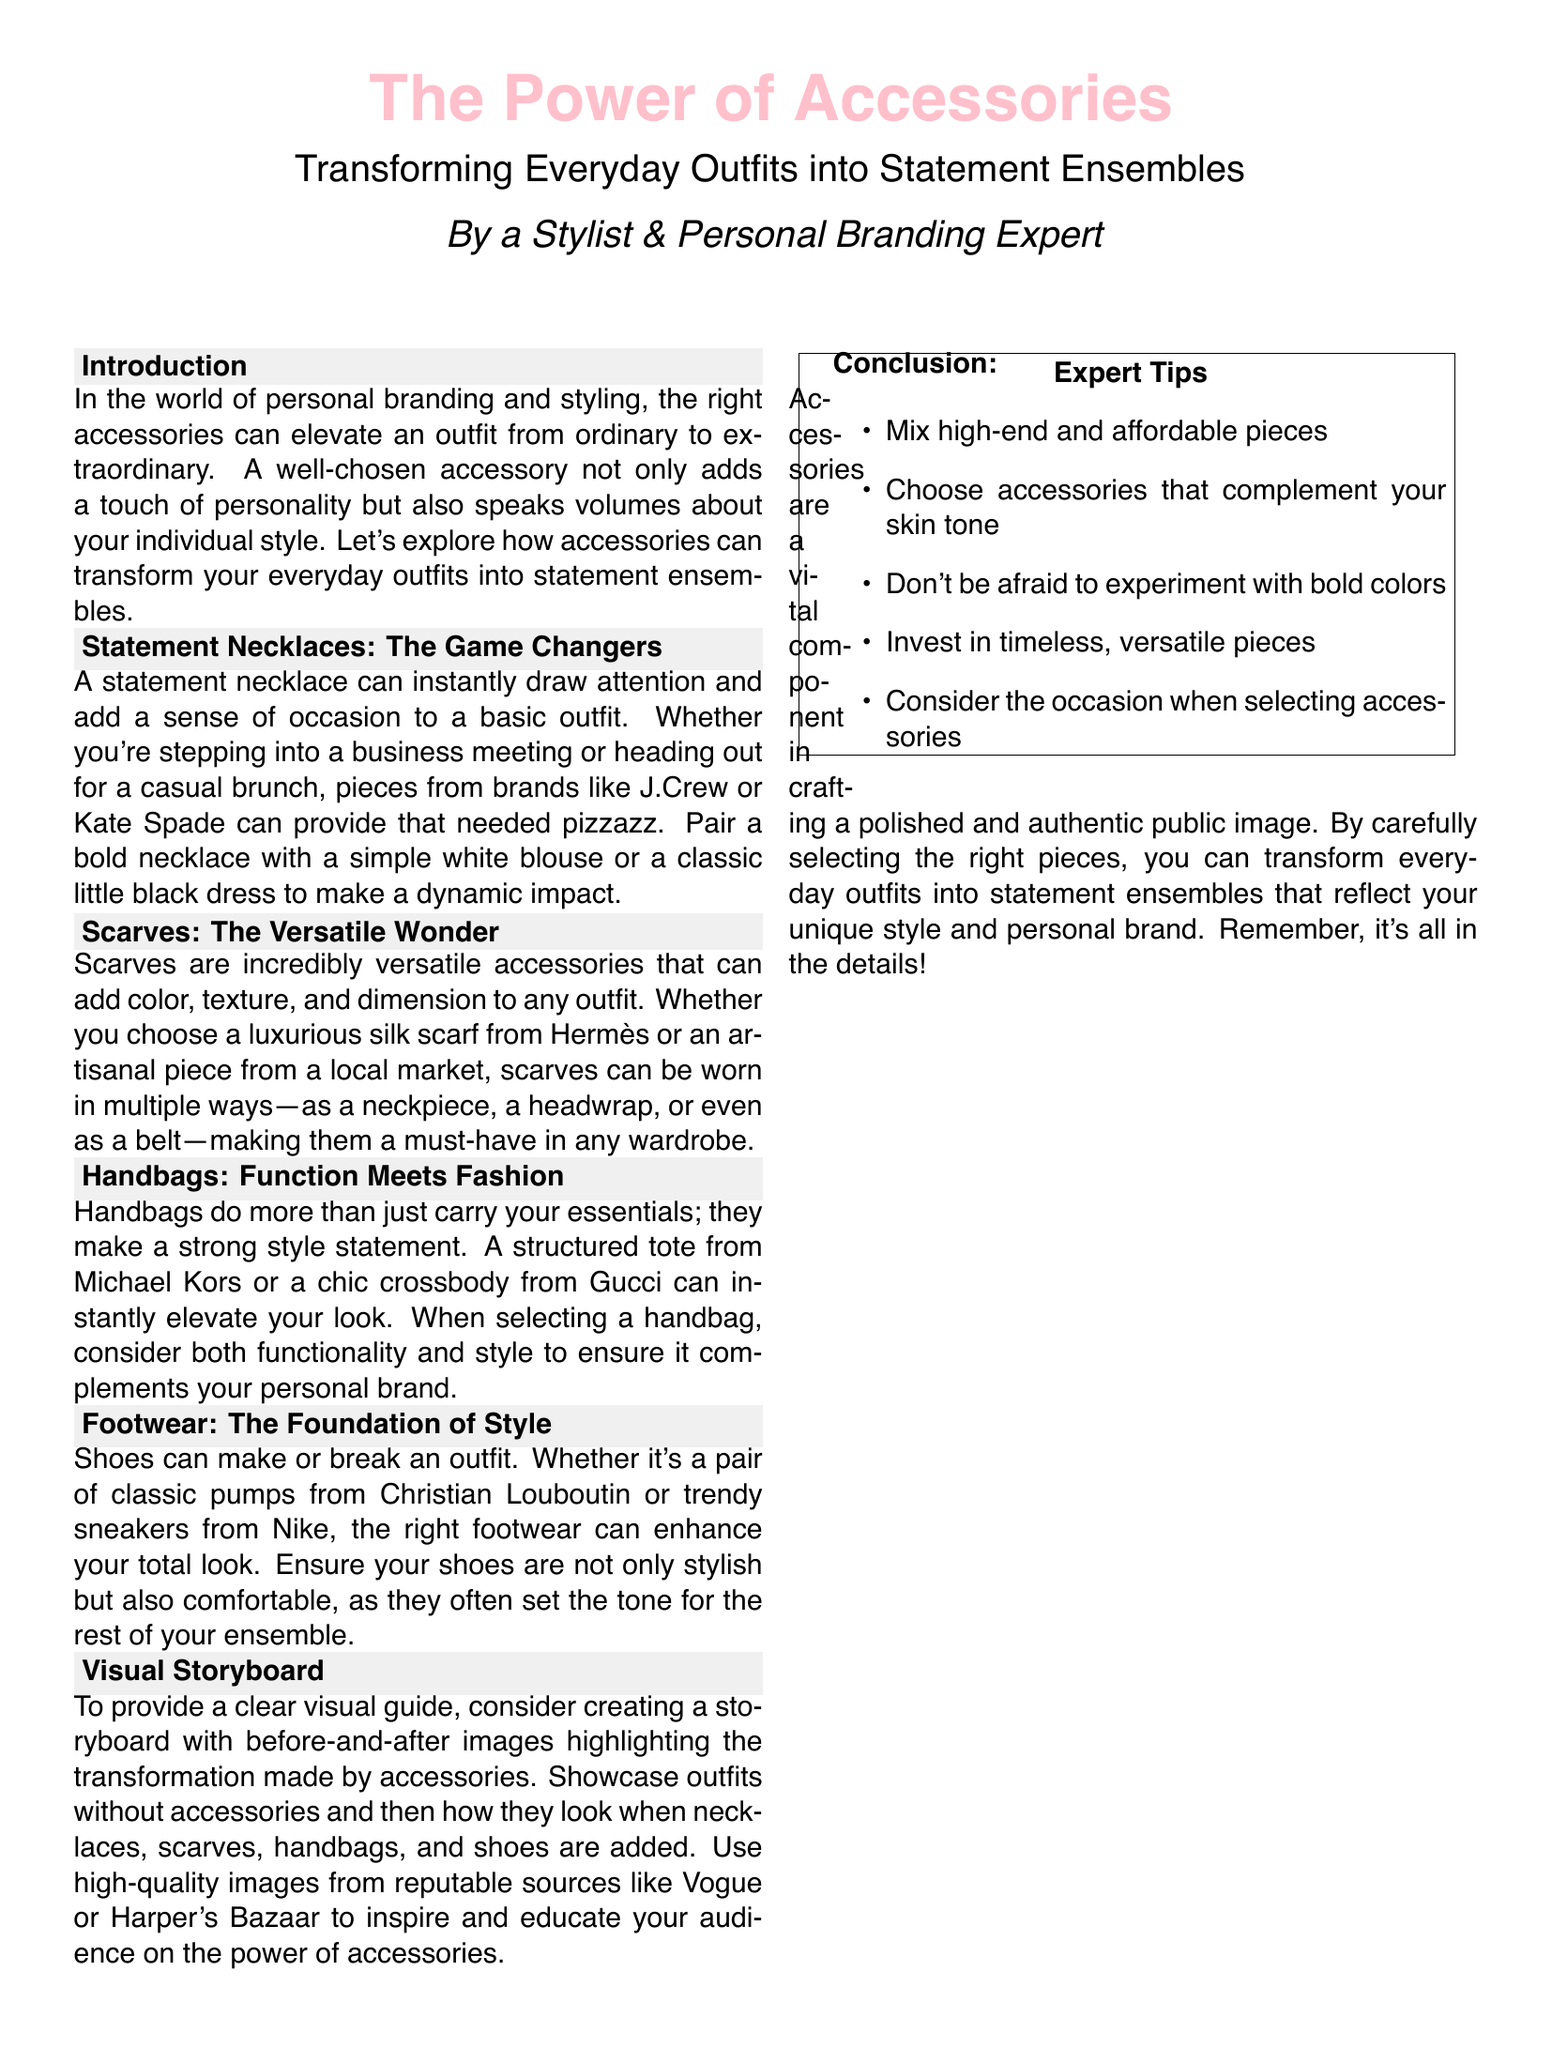What is the title of the document? The title of the document is prominently displayed at the top of the layout, emphasizing its main theme.
Answer: The Power of Accessories Who is the author of the document? The author's name is included below the title, indicating their expertise in the subject matter.
Answer: A Stylist & Personal Branding Expert What accessory is highlighted as a game changer? The document specifically identifies a type of accessory that can significantly enhance an outfit.
Answer: Statement Necklaces Which brand is mentioned for structured totes? The text refers to a well-known brand that provides a specific type of handbag.
Answer: Michael Kors What is the primary function of handbags according to the document? The document explains the dual role of handbags in terms of style and utility.
Answer: Function Meets Fashion How many expert tips are provided in the document? The expert tips section lists a specific quantity of recommendations for accessorizing.
Answer: Five What can scarves add to an outfit? The document describes the impact of scarves on the appearance of an outfit in terms of style.
Answer: Color, texture, and dimension What is suggested to create for visual guidance? The document emphasizes the importance of visual aids to illustrate the transformation achieved through styling.
Answer: A storyboard 